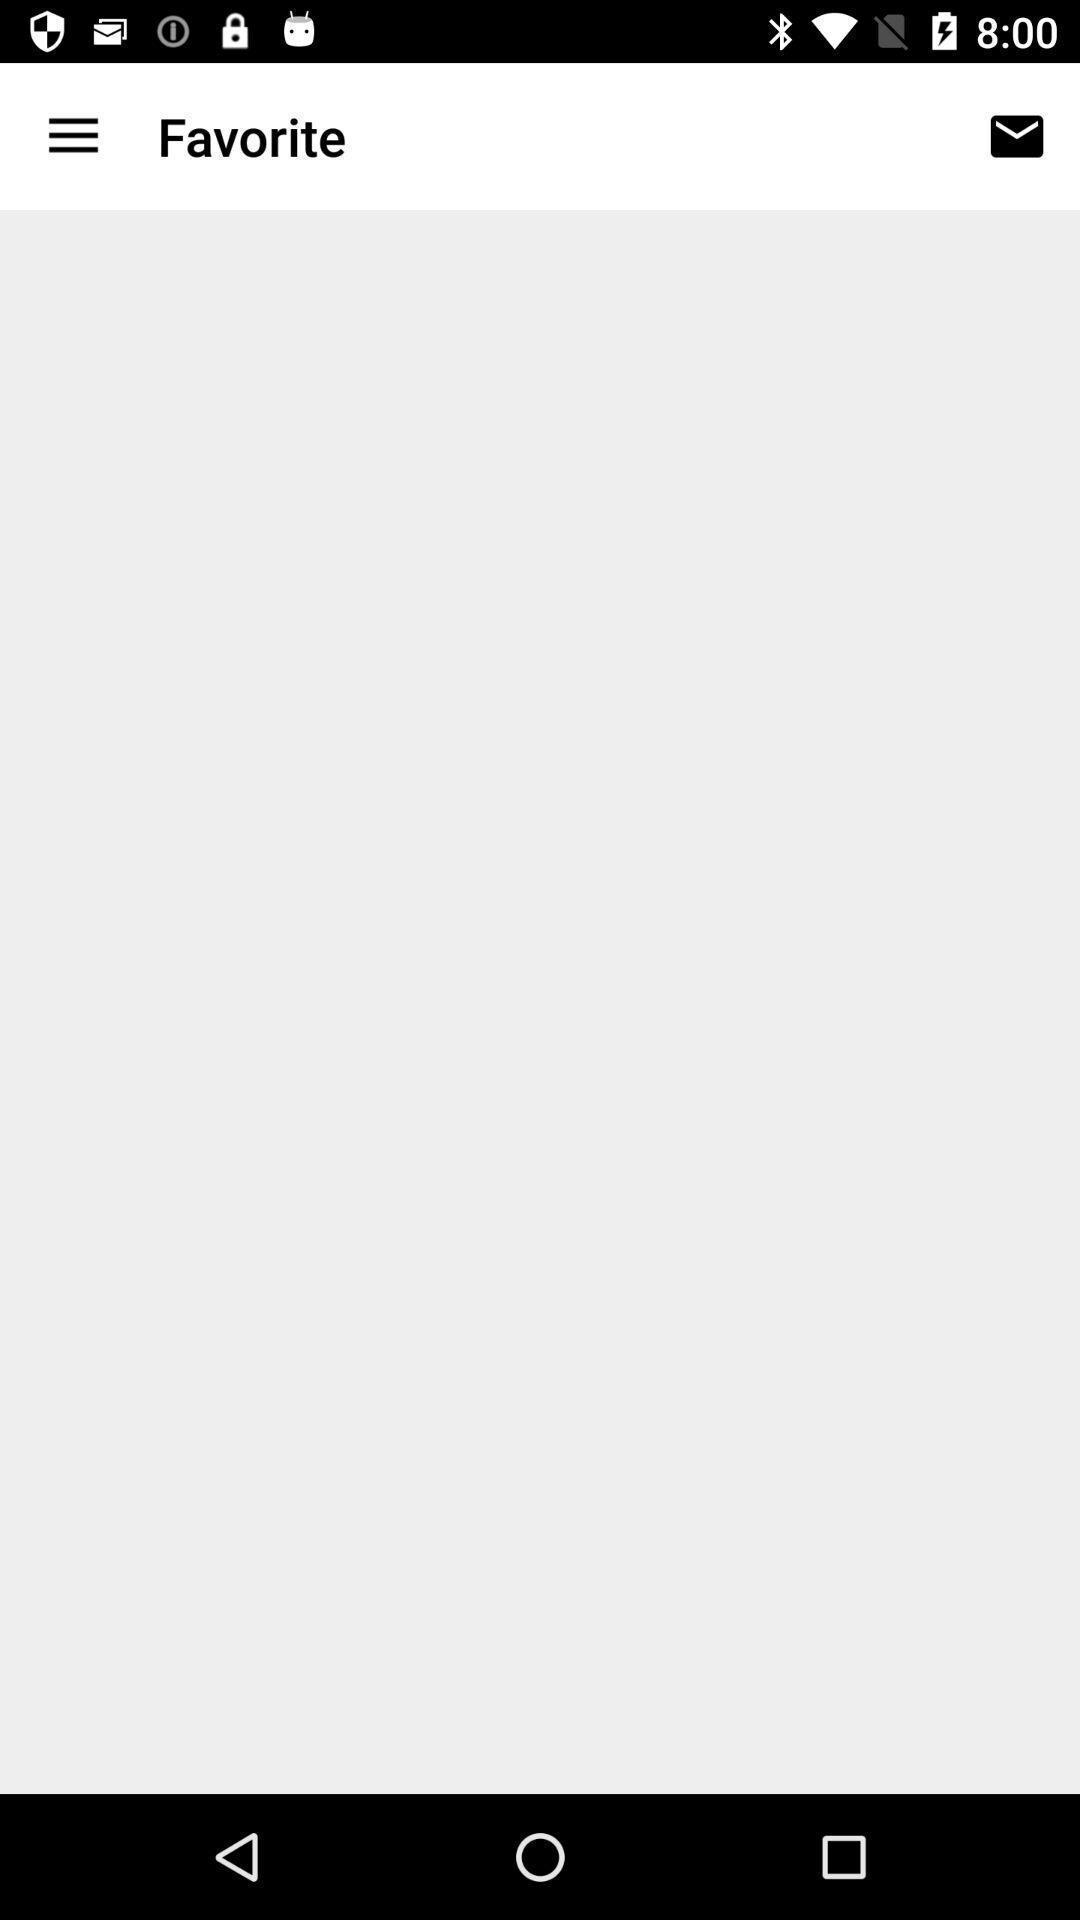Describe the key features of this screenshot. Page displaying favorite. 